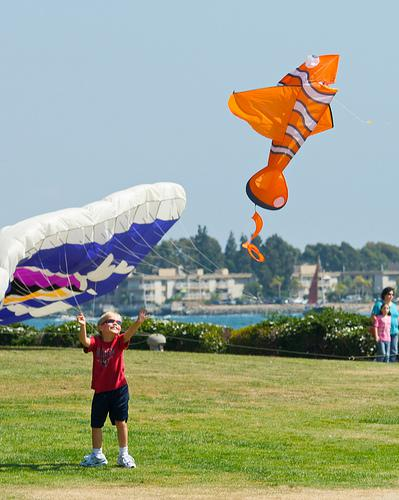Question: where are kites?
Choices:
A. On the ground.
B. In the tree.
C. In the kids' hands.
D. In the air.
Answer with the letter. Answer: D Question: who is flying kites?
Choices:
A. A kid.
B. A man.
C. A woman.
D. An old woman.
Answer with the letter. Answer: A Question: how many children are flying kites?
Choices:
A. One.
B. Two.
C. Three.
D. Four.
Answer with the letter. Answer: A Question: what is red?
Choices:
A. A kid's shirt.
B. A chair.
C. A kite.
D. A flag.
Answer with the letter. Answer: A Question: what is blue?
Choices:
A. Sky.
B. Helmet.
C. Shirt.
D. Bench.
Answer with the letter. Answer: A Question: what is in the distance?
Choices:
A. Buildings.
B. Art installation.
C. A crowd.
D. Trees.
Answer with the letter. Answer: D 